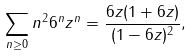Convert formula to latex. <formula><loc_0><loc_0><loc_500><loc_500>\sum _ { n \geq 0 } n ^ { 2 } 6 ^ { n } z ^ { n } = \frac { 6 z ( 1 + 6 z ) } { ( 1 - 6 z ) ^ { 2 } } ,</formula> 